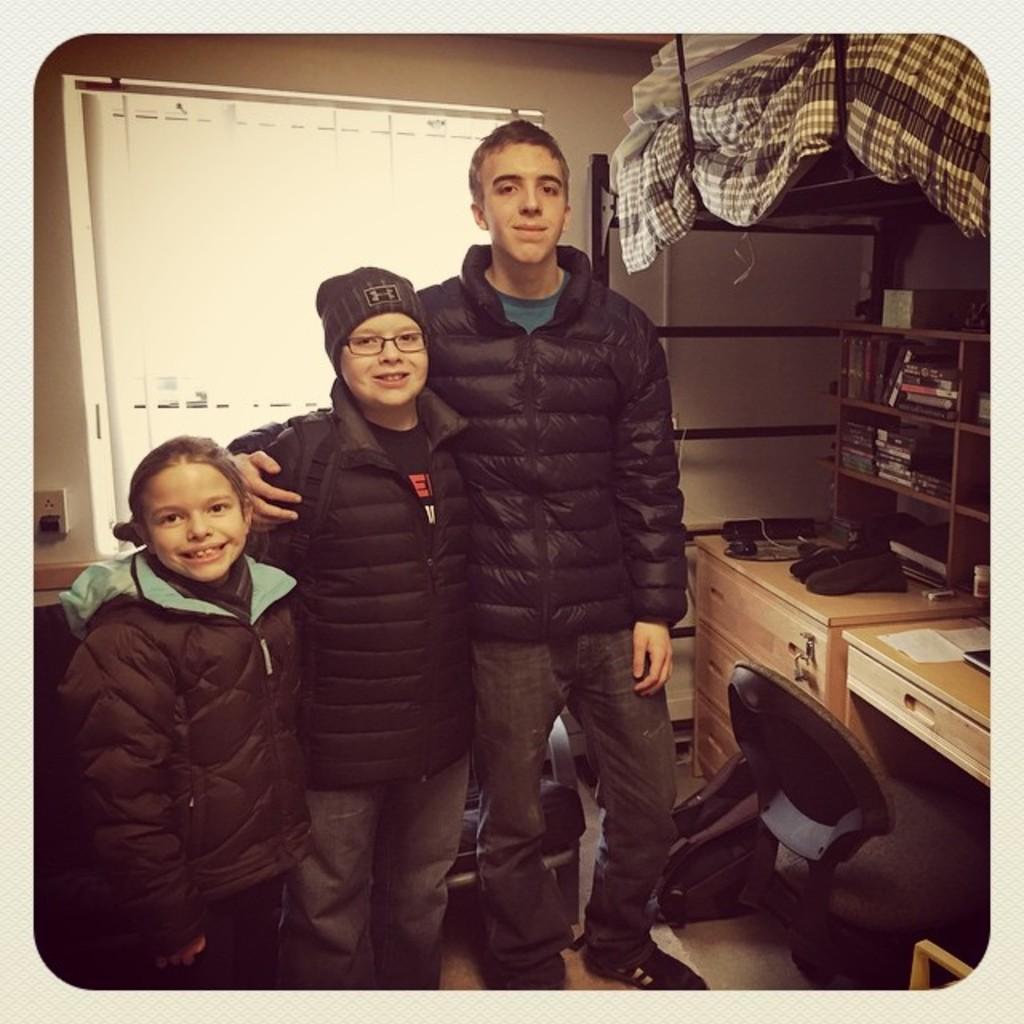In one or two sentences, can you explain what this image depicts? There are three members here wearing a black jackets and posing for a picture. One of them is a girl. Two of them are men. In the background there is a window. Beside them there is a table on which some of the accessories are placed and cupboard in which books are placed. 